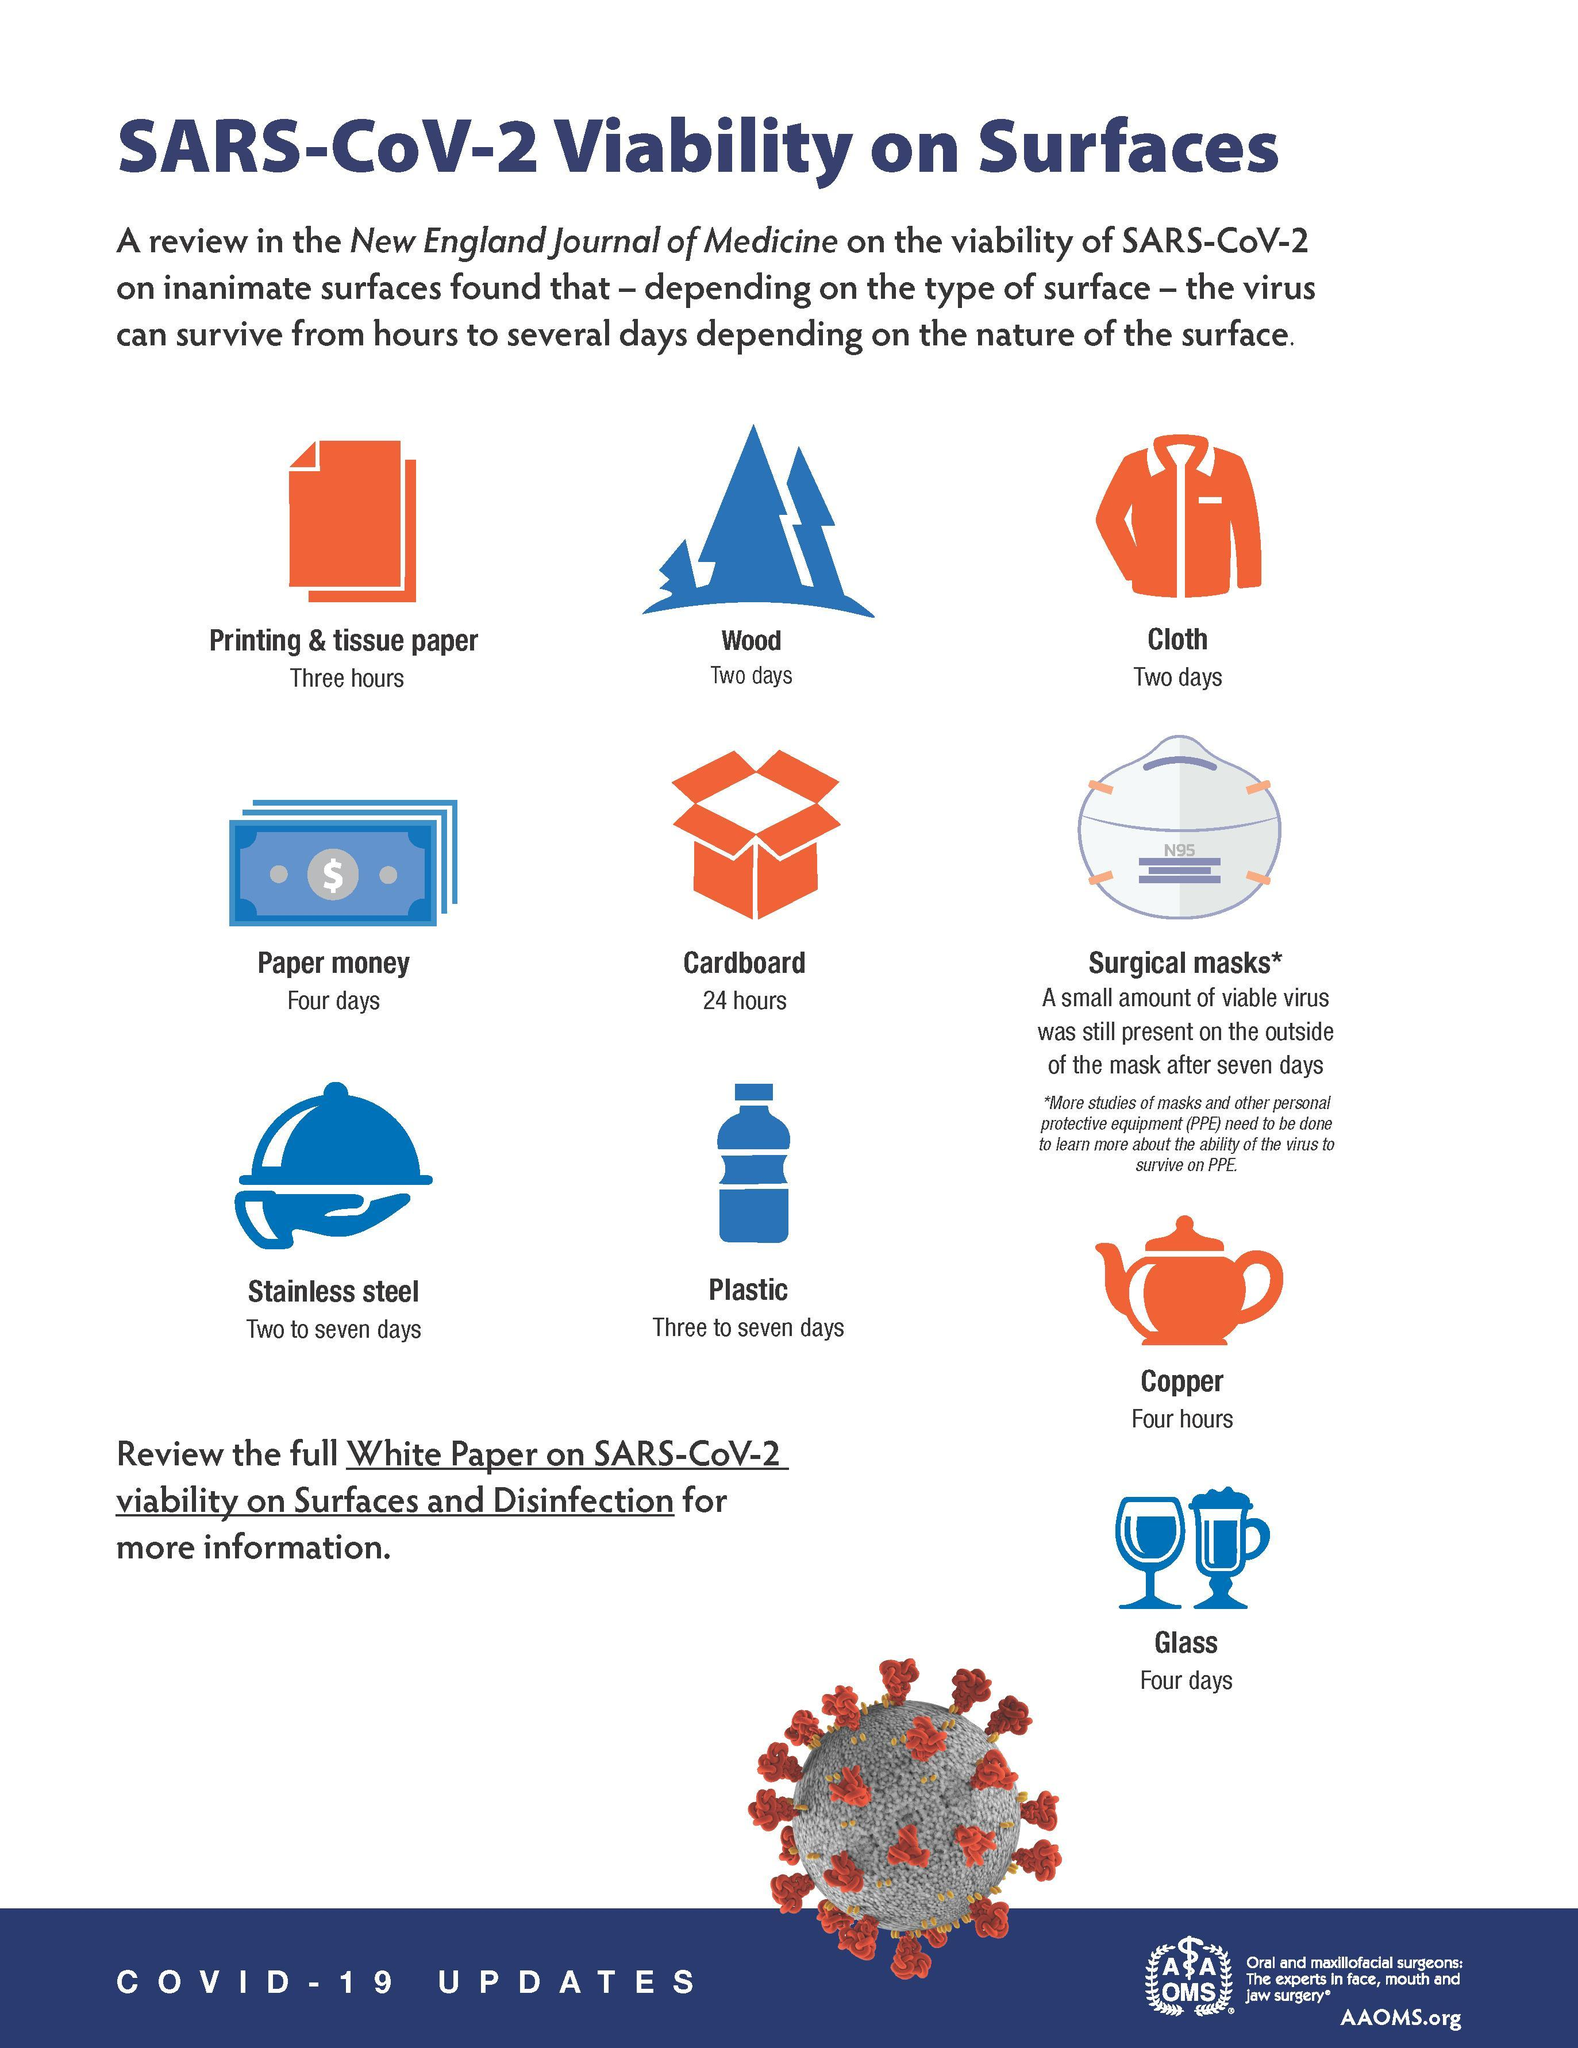How long corona virus will be active on Cloth?
Answer the question with a short phrase. Two days Which is the second suitable area for corona virus to stick on? plastic On which surface SARS-CoV-2 virus stay for two to seven days? Stainless steel Which are the surfaces at which Corona Virus can withstand up to only two days? Wood, Cloth Which is the surface at which corona virus will be active for 3 to 7 days? Plastic Which is the surface best suited for SARS-CoV-2 to stay long? Surgical masks How long corona virus will be active on the plastic surface? three to seven days How long the virus can stay on the surface of Cardboard? 24 hours On which area corona virus can stay for up to three hours? Printing & tissue paper Which is the fourth surface mentioned in the infographic? Paper money 